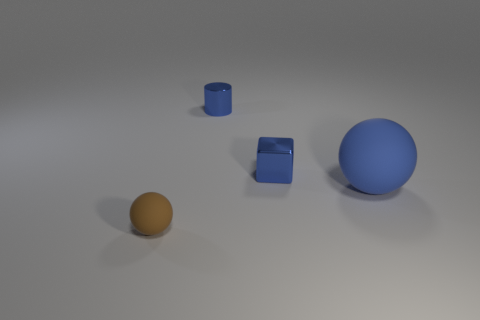Is there any other thing that has the same size as the blue sphere?
Keep it short and to the point. No. Do the big thing and the tiny cylinder have the same color?
Your response must be concise. Yes. What is the material of the ball that is the same color as the small shiny block?
Ensure brevity in your answer.  Rubber. Are there an equal number of small blue objects to the right of the blue cylinder and big blue balls?
Your answer should be compact. Yes. There is a tiny sphere; are there any small matte objects behind it?
Your answer should be very brief. No. There is a tiny brown object; is its shape the same as the shiny object behind the blue metallic cube?
Offer a terse response. No. There is another large thing that is the same material as the brown thing; what is its color?
Your answer should be compact. Blue. The cube has what color?
Offer a very short reply. Blue. Do the big blue thing and the object in front of the big thing have the same material?
Keep it short and to the point. Yes. What number of things are behind the tiny shiny block and to the right of the small blue cube?
Give a very brief answer. 0. 